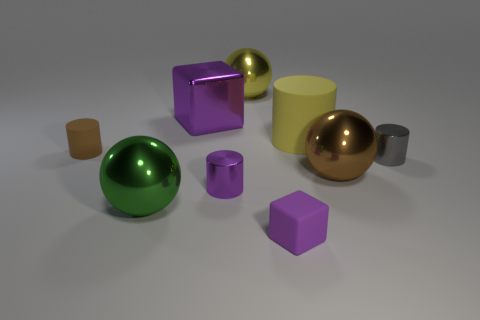Subtract 1 cylinders. How many cylinders are left? 3 Subtract all cyan spheres. Subtract all blue cylinders. How many spheres are left? 3 Subtract all cylinders. How many objects are left? 5 Subtract all green objects. Subtract all gray cylinders. How many objects are left? 7 Add 1 big brown metal balls. How many big brown metal balls are left? 2 Add 9 purple shiny cylinders. How many purple shiny cylinders exist? 10 Subtract 1 brown balls. How many objects are left? 8 